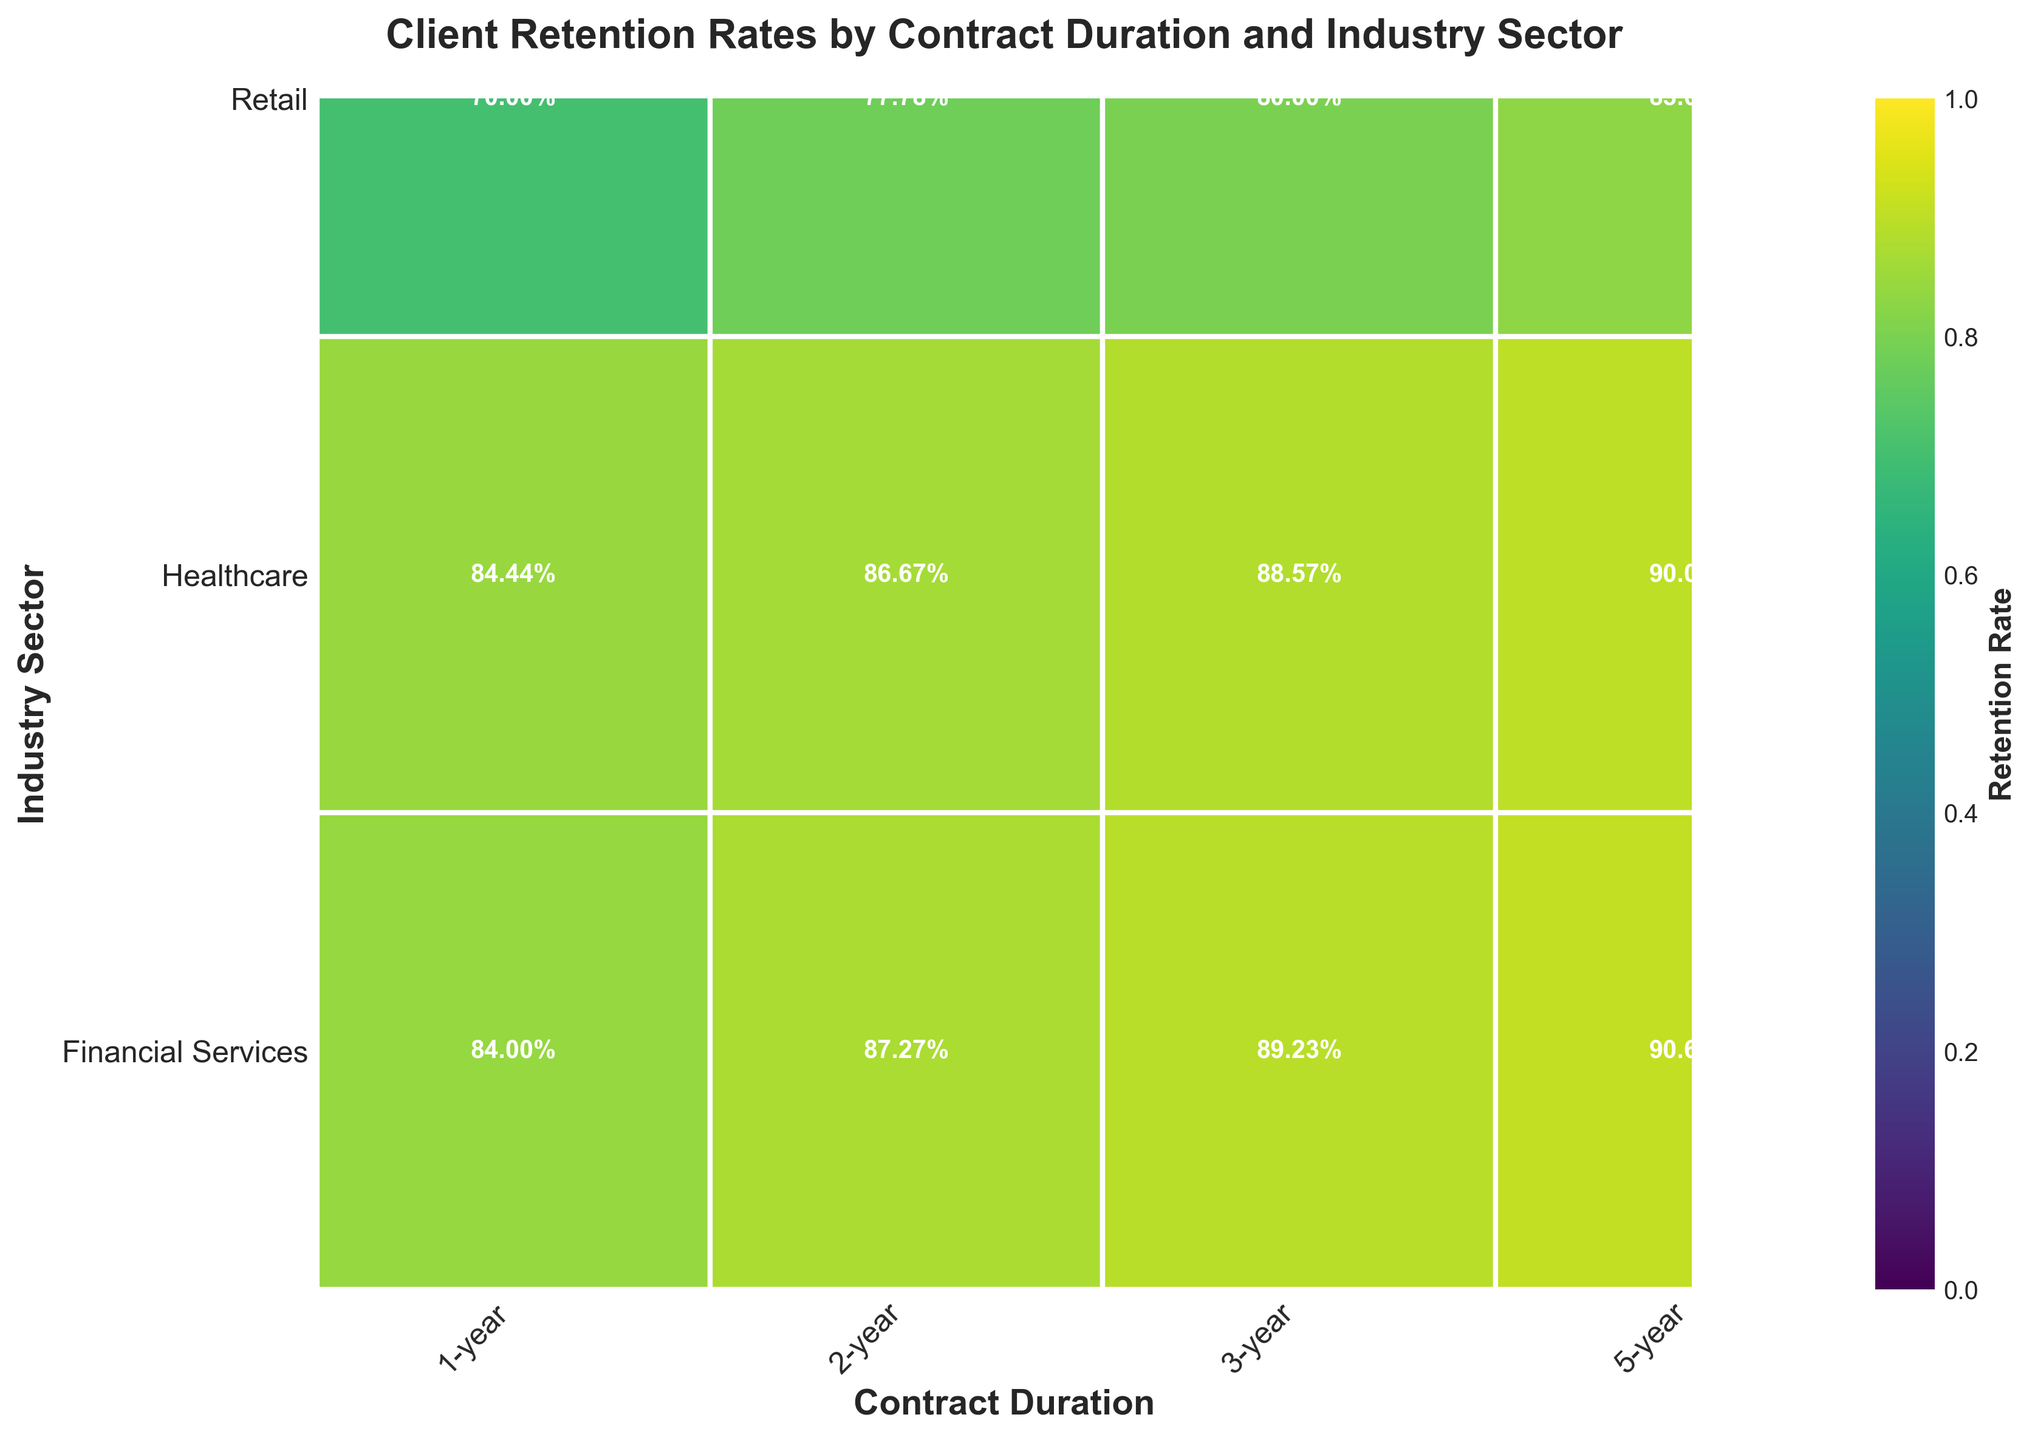What is the title of the figure? The title is displayed at the top of the figure. It summarizes the main focus of the chart.
Answer: Client Retention Rates by Contract Duration and Industry Sector What are the labels for the X and Y axes? The X and Y axis labels are usually displayed along the respective axes. They describe what is being measured on each axis.
Answer: Contract Duration (X-axis) and Industry Sector (Y-axis) Which industry sector has the lowest retention rate for 1-year contracts? By examining the color intensity for 1-year contracts in the different industry sectors, the sector with the least intense (lightest) color has the lowest retention rate.
Answer: Retail How does the retention rate in the Healthcare sector compare between 2-year and 5-year contracts? By comparing the color intensity or the percentage labels for the Healthcare sector between the 2-year and 5-year contracts, we can see which has a higher value.
Answer: Higher for 5-year Which contract duration and sector combination shows the highest retention rate? By scanning through all combinations of contract duration and industry sectors, the most intense color or highest percentage label indicates the highest retention rate.
Answer: 5-year Healthcare Is the retention rate in the Financial Services sector always higher than in the Retail sector for the same contract duration? For each contract duration, compare the retention rates (color intensity and percentage labels) between Financial Services and Retail sectors to check if Retail is always lower.
Answer: Yes For which contract duration is the retention rate in the Healthcare sector approximately 90%? By looking at the Healthcare sector data across different contract durations and finding the one close to 90%, we can identify the duration.
Answer: 5-year What's the difference in retention rates between 1-year and 5-year contracts for the Financial Services sector? Find the retention rates for 1-year and 5-year contracts in the Financial Services sector and subtract the lower value from the higher one to get the difference.
Answer: 34% Which industry sector shows the smallest variation in retention rates across different contract durations? Calculate the difference between the highest and lowest retention rates for each industry sector across all contract durations and compare these variations.
Answer: Healthcare 